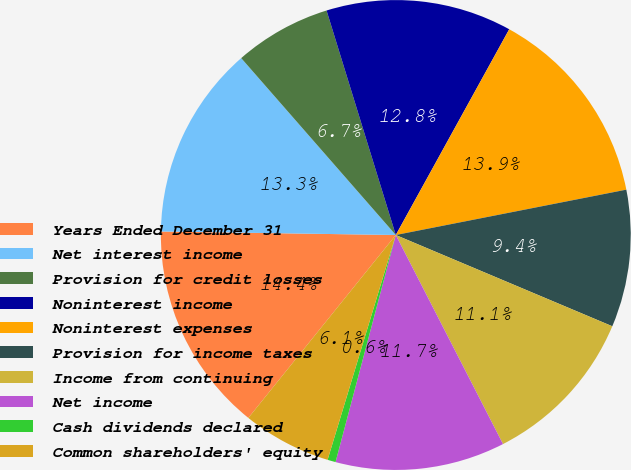Convert chart. <chart><loc_0><loc_0><loc_500><loc_500><pie_chart><fcel>Years Ended December 31<fcel>Net interest income<fcel>Provision for credit losses<fcel>Noninterest income<fcel>Noninterest expenses<fcel>Provision for income taxes<fcel>Income from continuing<fcel>Net income<fcel>Cash dividends declared<fcel>Common shareholders' equity<nl><fcel>14.44%<fcel>13.33%<fcel>6.67%<fcel>12.78%<fcel>13.89%<fcel>9.44%<fcel>11.11%<fcel>11.67%<fcel>0.56%<fcel>6.11%<nl></chart> 